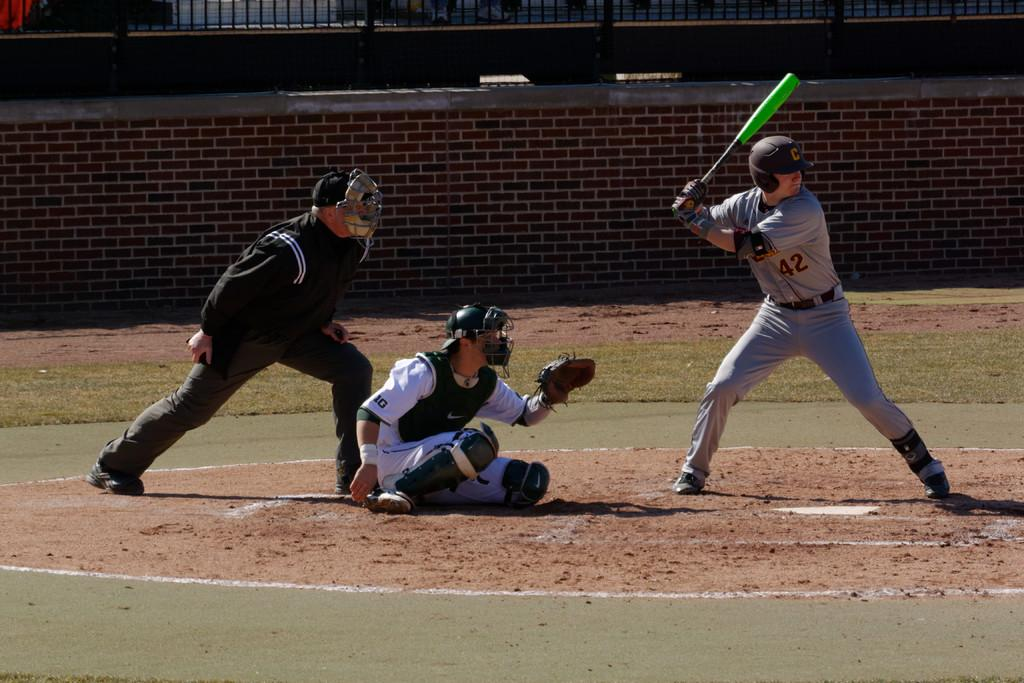What sport are the people playing in the image? The people are playing baseball in the image. What type of surface are the players on? There is grass on the surface at the bottom of the image. What can be seen in the background of the image? There is a wall in the background of the image. What type of barrier is present in the image? There is a metal fence in the image. What shape is the mind of the person batting in the image? The image does not provide information about the shape of anyone's mind, as it is not visible. 